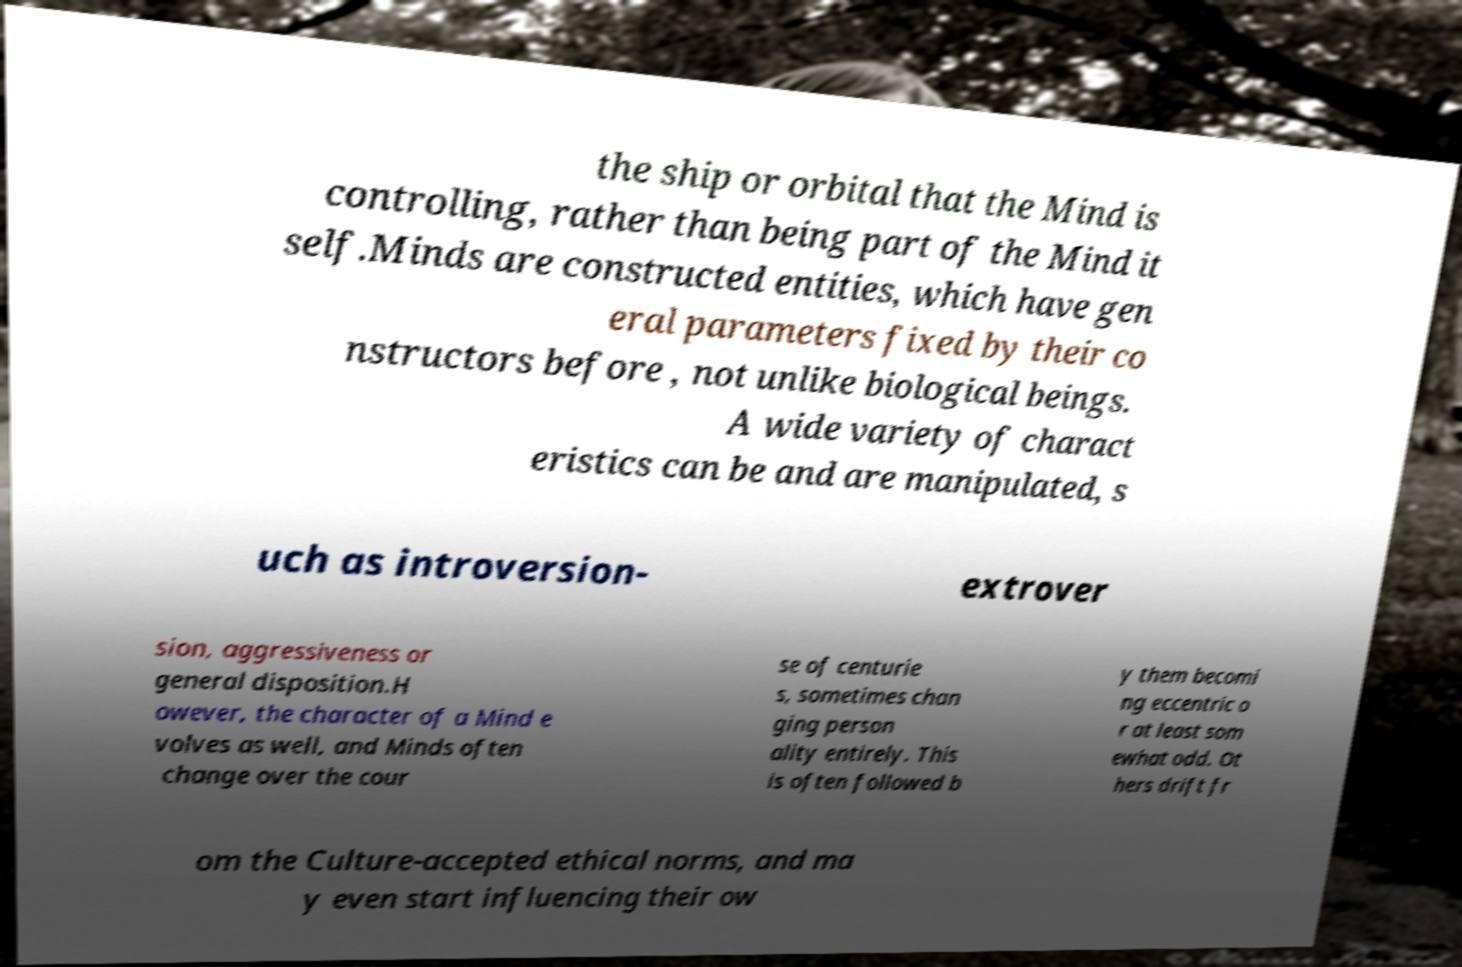What messages or text are displayed in this image? I need them in a readable, typed format. the ship or orbital that the Mind is controlling, rather than being part of the Mind it self.Minds are constructed entities, which have gen eral parameters fixed by their co nstructors before , not unlike biological beings. A wide variety of charact eristics can be and are manipulated, s uch as introversion- extrover sion, aggressiveness or general disposition.H owever, the character of a Mind e volves as well, and Minds often change over the cour se of centurie s, sometimes chan ging person ality entirely. This is often followed b y them becomi ng eccentric o r at least som ewhat odd. Ot hers drift fr om the Culture-accepted ethical norms, and ma y even start influencing their ow 